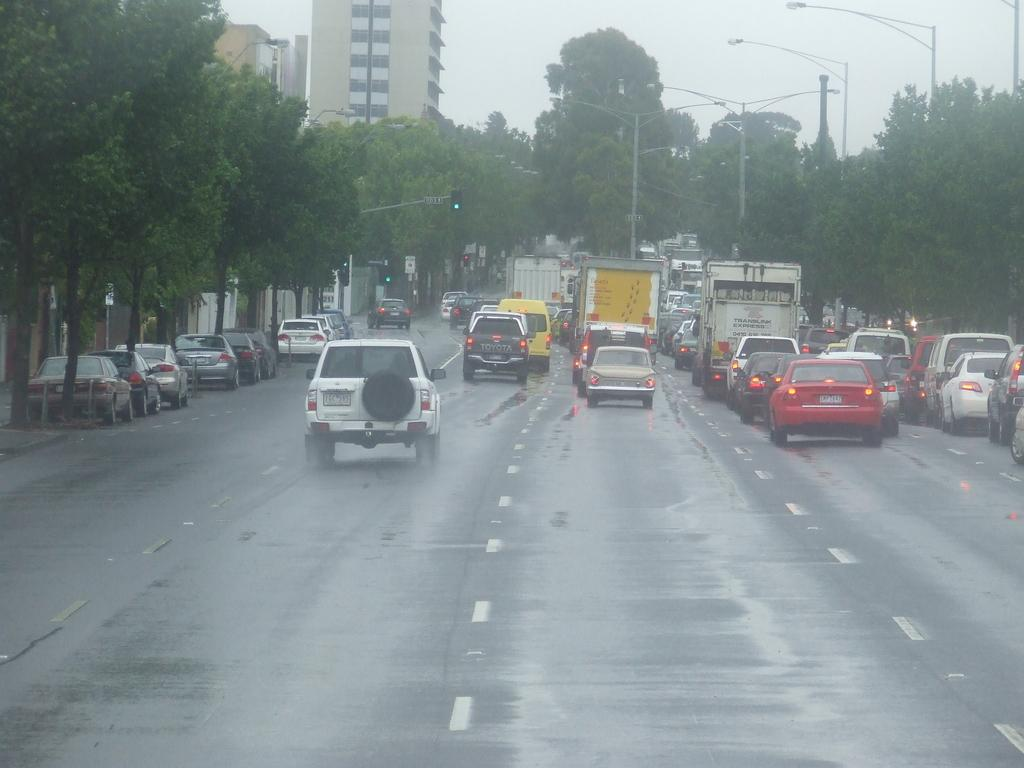What can be seen on the road in the image? There are vehicles on the road in the image. What type of natural elements are visible in the image? There are trees visible in the image. What helps regulate traffic in the image? There are traffic signals in the image. What type of structures can be seen in the image? There are buildings in the image. What are the poles with lights used for in the image? The poles with lights are likely used for illumination or signaling. What other objects can be seen in the image? There are other objects in the image, but their specific details are not mentioned in the provided facts. What is visible in the background of the image? The sky is visible in the background of the image. Can you see any goldfish swimming in the image? There are no goldfish present in the image. What season is depicted in the image? The provided facts do not mention any specific season or time of year. 